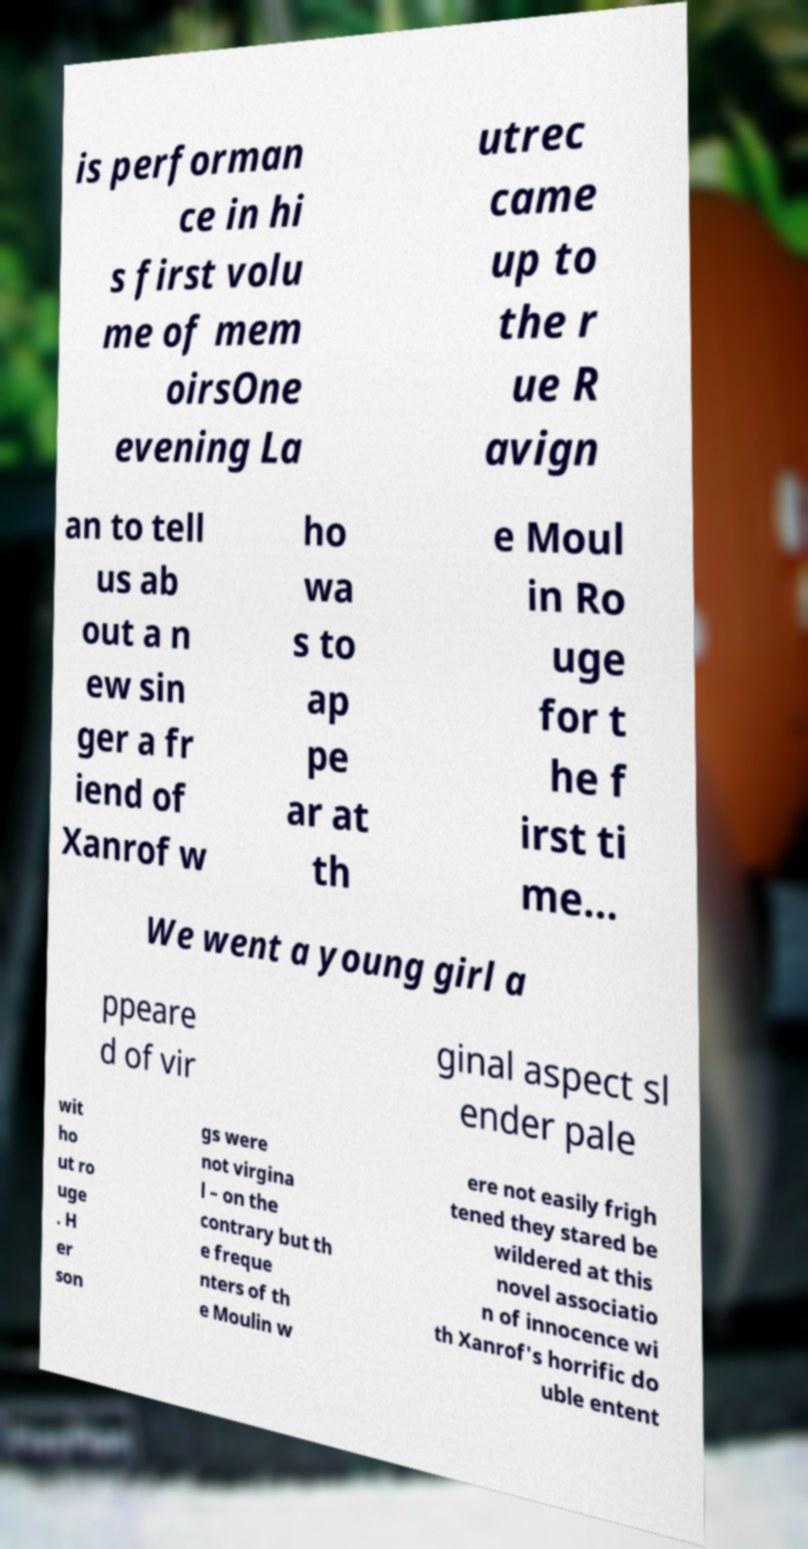Could you extract and type out the text from this image? is performan ce in hi s first volu me of mem oirsOne evening La utrec came up to the r ue R avign an to tell us ab out a n ew sin ger a fr iend of Xanrof w ho wa s to ap pe ar at th e Moul in Ro uge for t he f irst ti me... We went a young girl a ppeare d of vir ginal aspect sl ender pale wit ho ut ro uge . H er son gs were not virgina l – on the contrary but th e freque nters of th e Moulin w ere not easily frigh tened they stared be wildered at this novel associatio n of innocence wi th Xanrof's horrific do uble entent 